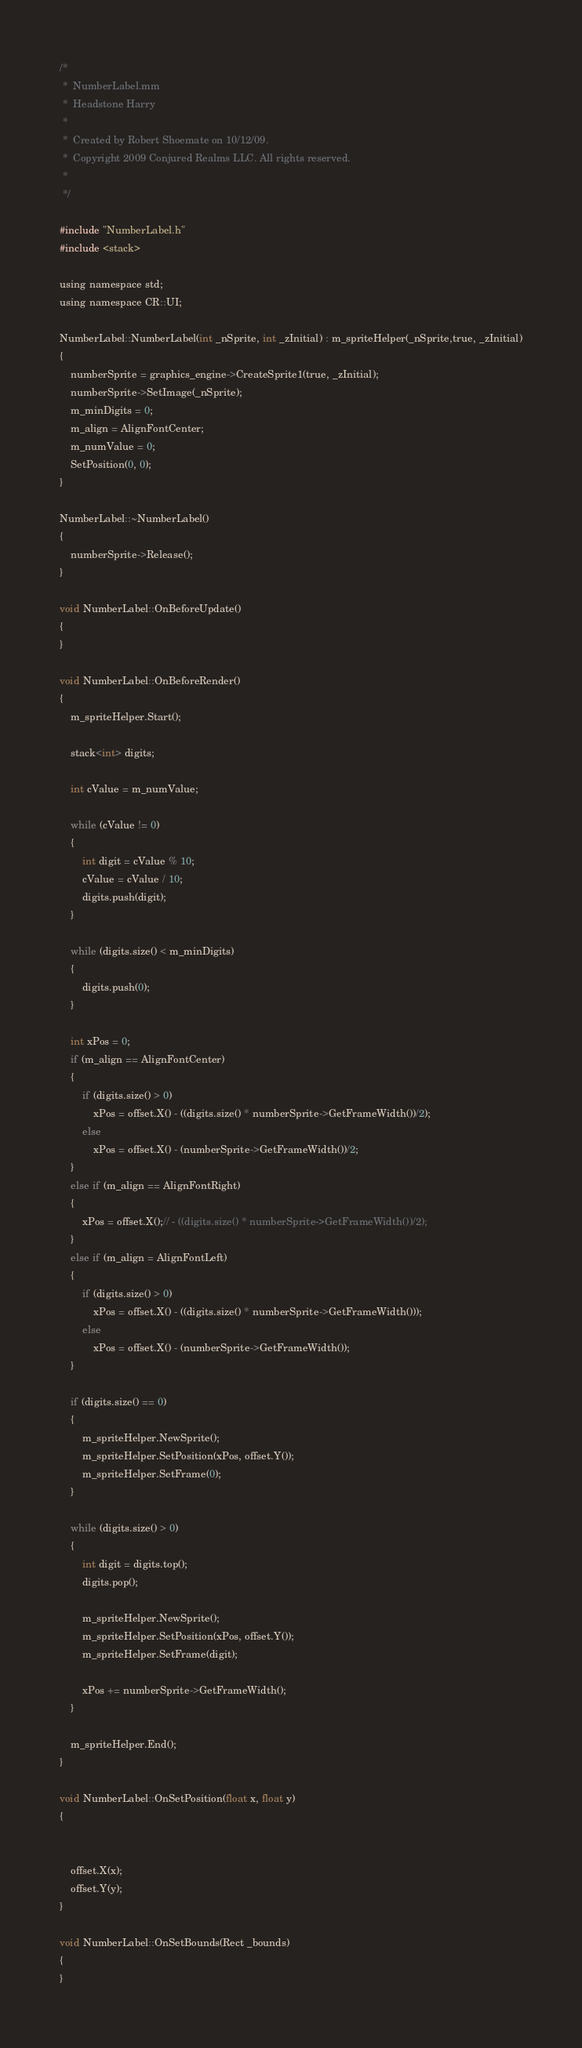Convert code to text. <code><loc_0><loc_0><loc_500><loc_500><_ObjectiveC_>/*
 *  NumberLabel.mm
 *  Headstone Harry
 *
 *  Created by Robert Shoemate on 10/12/09.
 *  Copyright 2009 Conjured Realms LLC. All rights reserved.
 *
 */

#include "NumberLabel.h"
#include <stack>

using namespace std;
using namespace CR::UI;

NumberLabel::NumberLabel(int _nSprite, int _zInitial) : m_spriteHelper(_nSprite,true, _zInitial)
{
	numberSprite = graphics_engine->CreateSprite1(true, _zInitial);
	numberSprite->SetImage(_nSprite);
	m_minDigits = 0;
	m_align = AlignFontCenter;
	m_numValue = 0;
	SetPosition(0, 0);
}

NumberLabel::~NumberLabel()
{
	numberSprite->Release();
}

void NumberLabel::OnBeforeUpdate()
{
}

void NumberLabel::OnBeforeRender()
{
	m_spriteHelper.Start();
	
	stack<int> digits;
	
	int cValue = m_numValue;
	
	while (cValue != 0)
	{
		int digit = cValue % 10;
		cValue = cValue / 10;
		digits.push(digit);
	}
	
	while (digits.size() < m_minDigits)
	{
		digits.push(0);
	}
	
	int xPos = 0;
	if (m_align == AlignFontCenter)
	{
		if (digits.size() > 0)
			xPos = offset.X() - ((digits.size() * numberSprite->GetFrameWidth())/2);
		else
			xPos = offset.X() - (numberSprite->GetFrameWidth())/2;
	}
	else if (m_align == AlignFontRight)
	{
		xPos = offset.X();// - ((digits.size() * numberSprite->GetFrameWidth())/2);
	}
	else if (m_align = AlignFontLeft)
	{
		if (digits.size() > 0)
			xPos = offset.X() - ((digits.size() * numberSprite->GetFrameWidth()));
		else
			xPos = offset.X() - (numberSprite->GetFrameWidth());
	}
	
	if (digits.size() == 0)
	{
		m_spriteHelper.NewSprite();
		m_spriteHelper.SetPosition(xPos, offset.Y());
		m_spriteHelper.SetFrame(0);
	}
	
	while (digits.size() > 0)
	{
		int digit = digits.top();
		digits.pop();
		
		m_spriteHelper.NewSprite();
		m_spriteHelper.SetPosition(xPos, offset.Y());
		m_spriteHelper.SetFrame(digit);
		
		xPos += numberSprite->GetFrameWidth();
	}
	
	m_spriteHelper.End();
}

void NumberLabel::OnSetPosition(float x, float y)
{

	
	offset.X(x);
	offset.Y(y);
}

void NumberLabel::OnSetBounds(Rect _bounds)
{
}</code> 